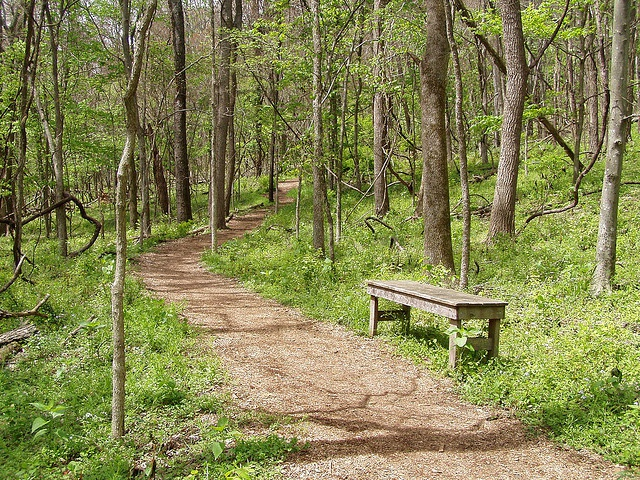Describe the objects in this image and their specific colors. I can see a bench in olive, darkgreen, beige, ivory, and black tones in this image. 